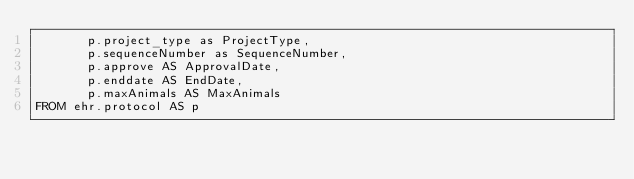Convert code to text. <code><loc_0><loc_0><loc_500><loc_500><_SQL_>       p.project_type as ProjectType,
       p.sequenceNumber as SequenceNumber,
       p.approve AS ApprovalDate,
       p.enddate AS EndDate,
       p.maxAnimals AS MaxAnimals
FROM ehr.protocol AS p
</code> 